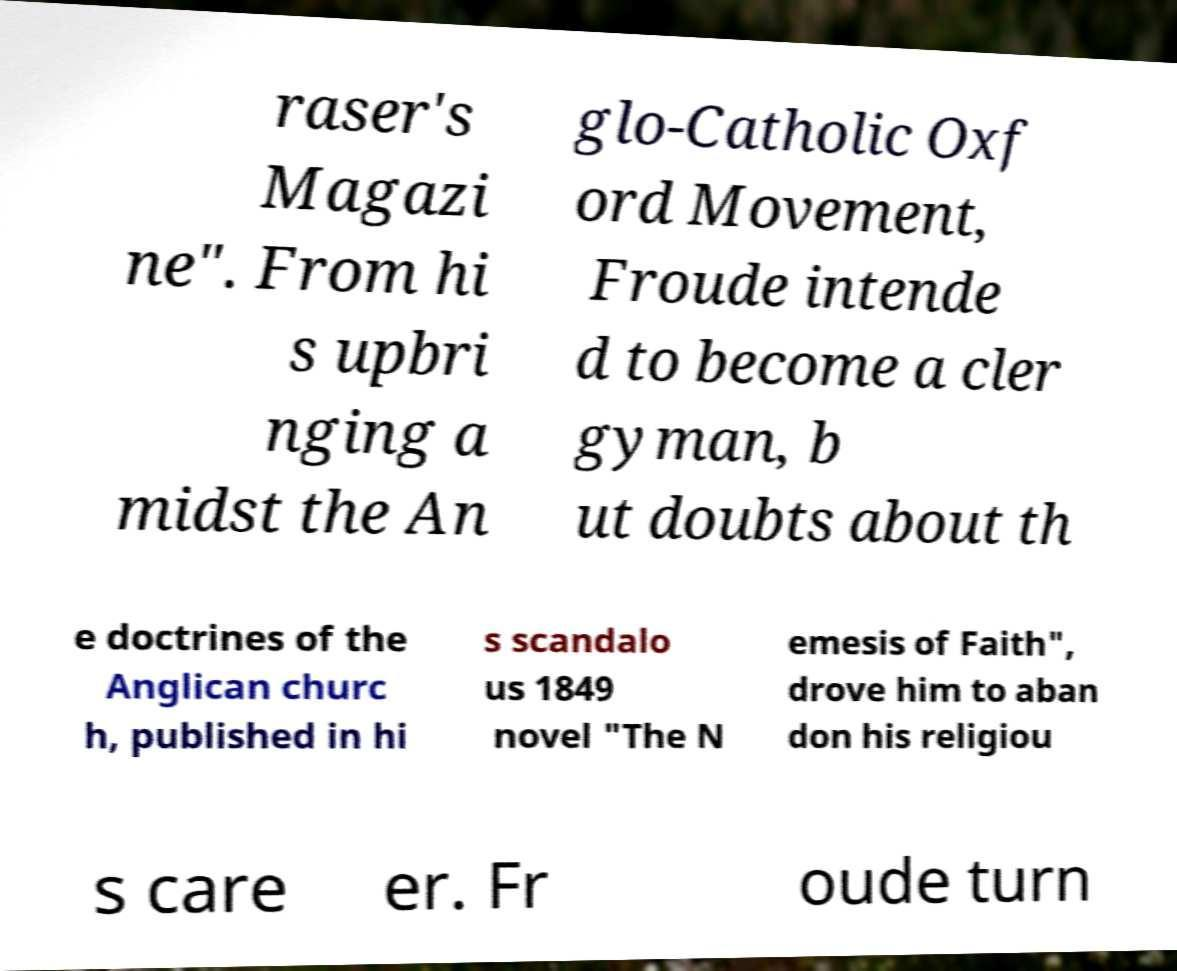For documentation purposes, I need the text within this image transcribed. Could you provide that? raser's Magazi ne". From hi s upbri nging a midst the An glo-Catholic Oxf ord Movement, Froude intende d to become a cler gyman, b ut doubts about th e doctrines of the Anglican churc h, published in hi s scandalo us 1849 novel "The N emesis of Faith", drove him to aban don his religiou s care er. Fr oude turn 